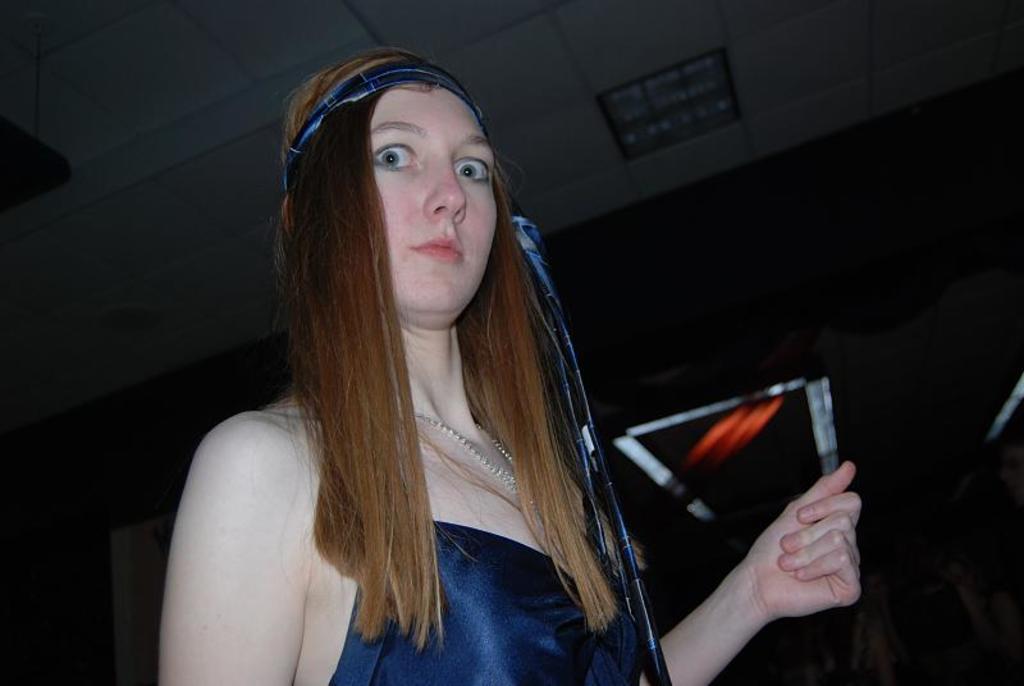Can you describe this image briefly? A woman is standing wearing a blue dress and there is a blue band on her head. 